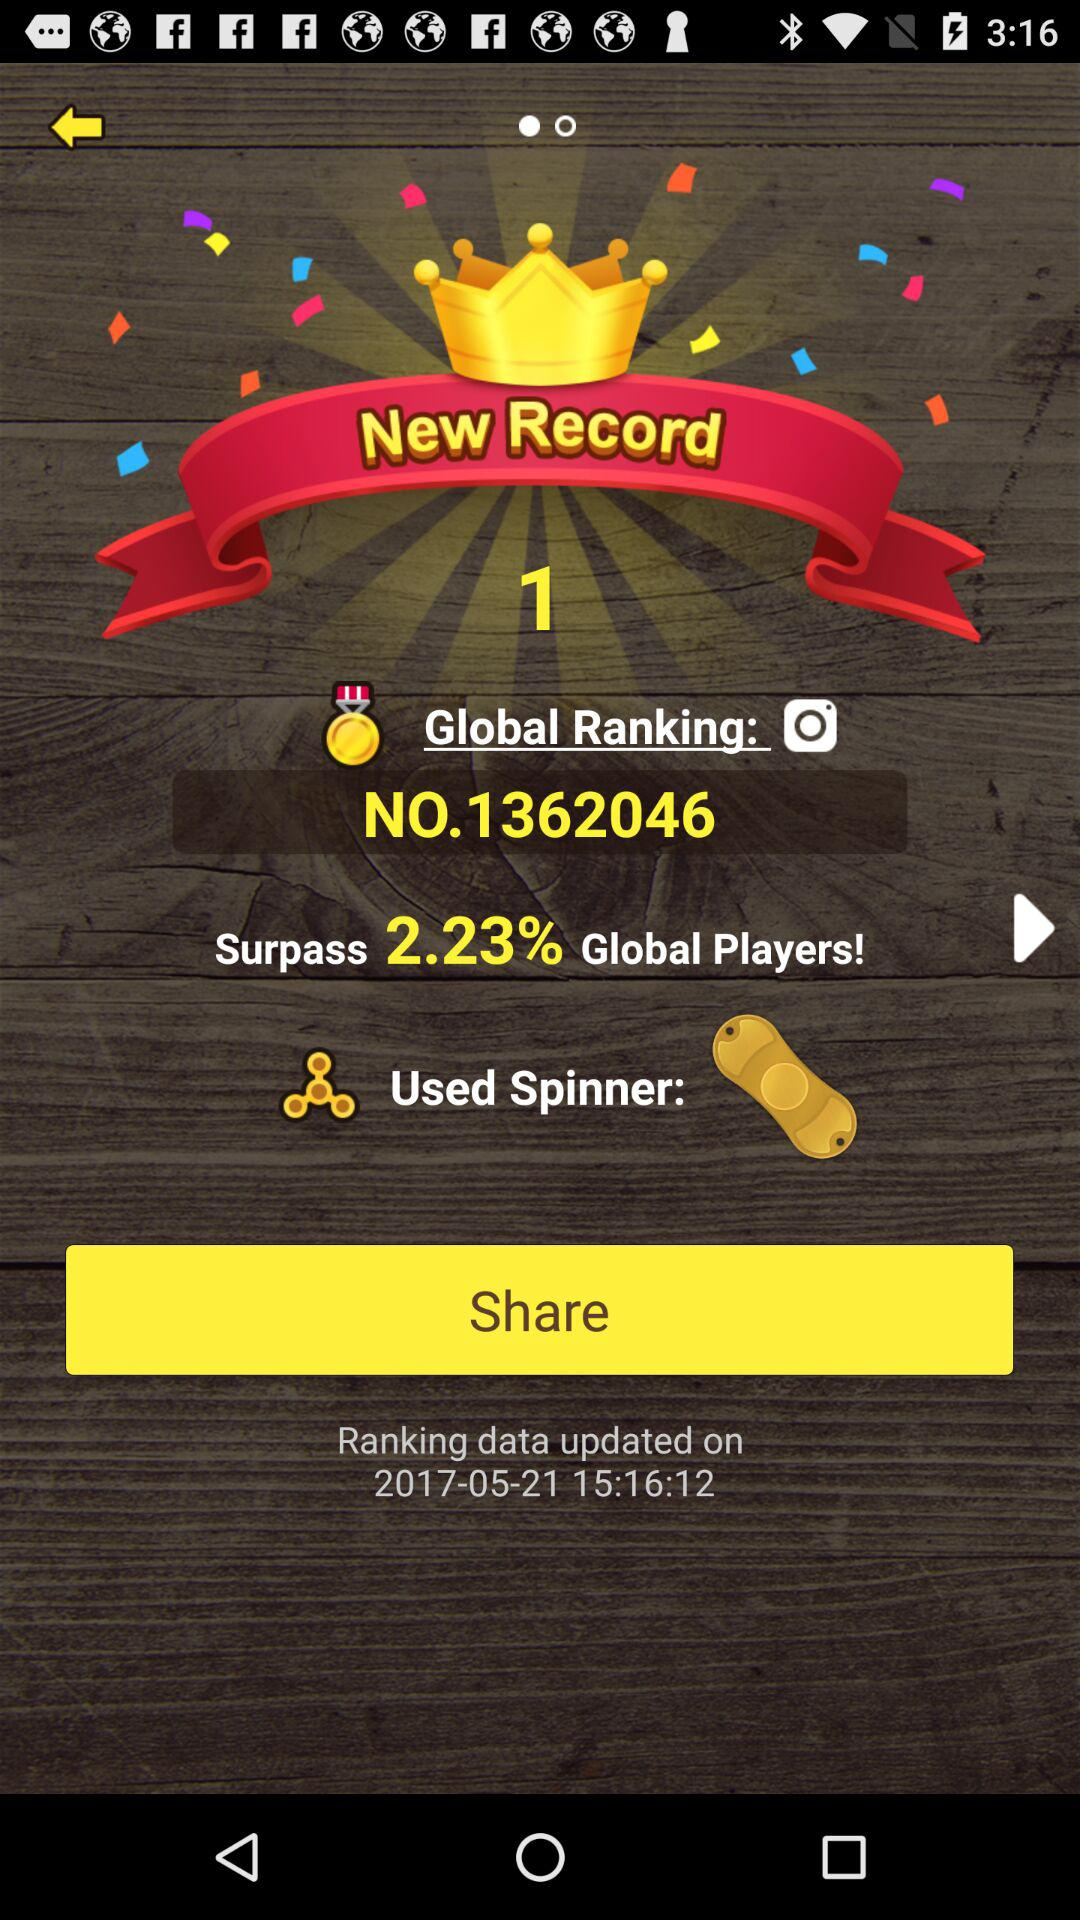What percentage of global players has the player surpassed? The player has surpassed 2.23% of global players. 